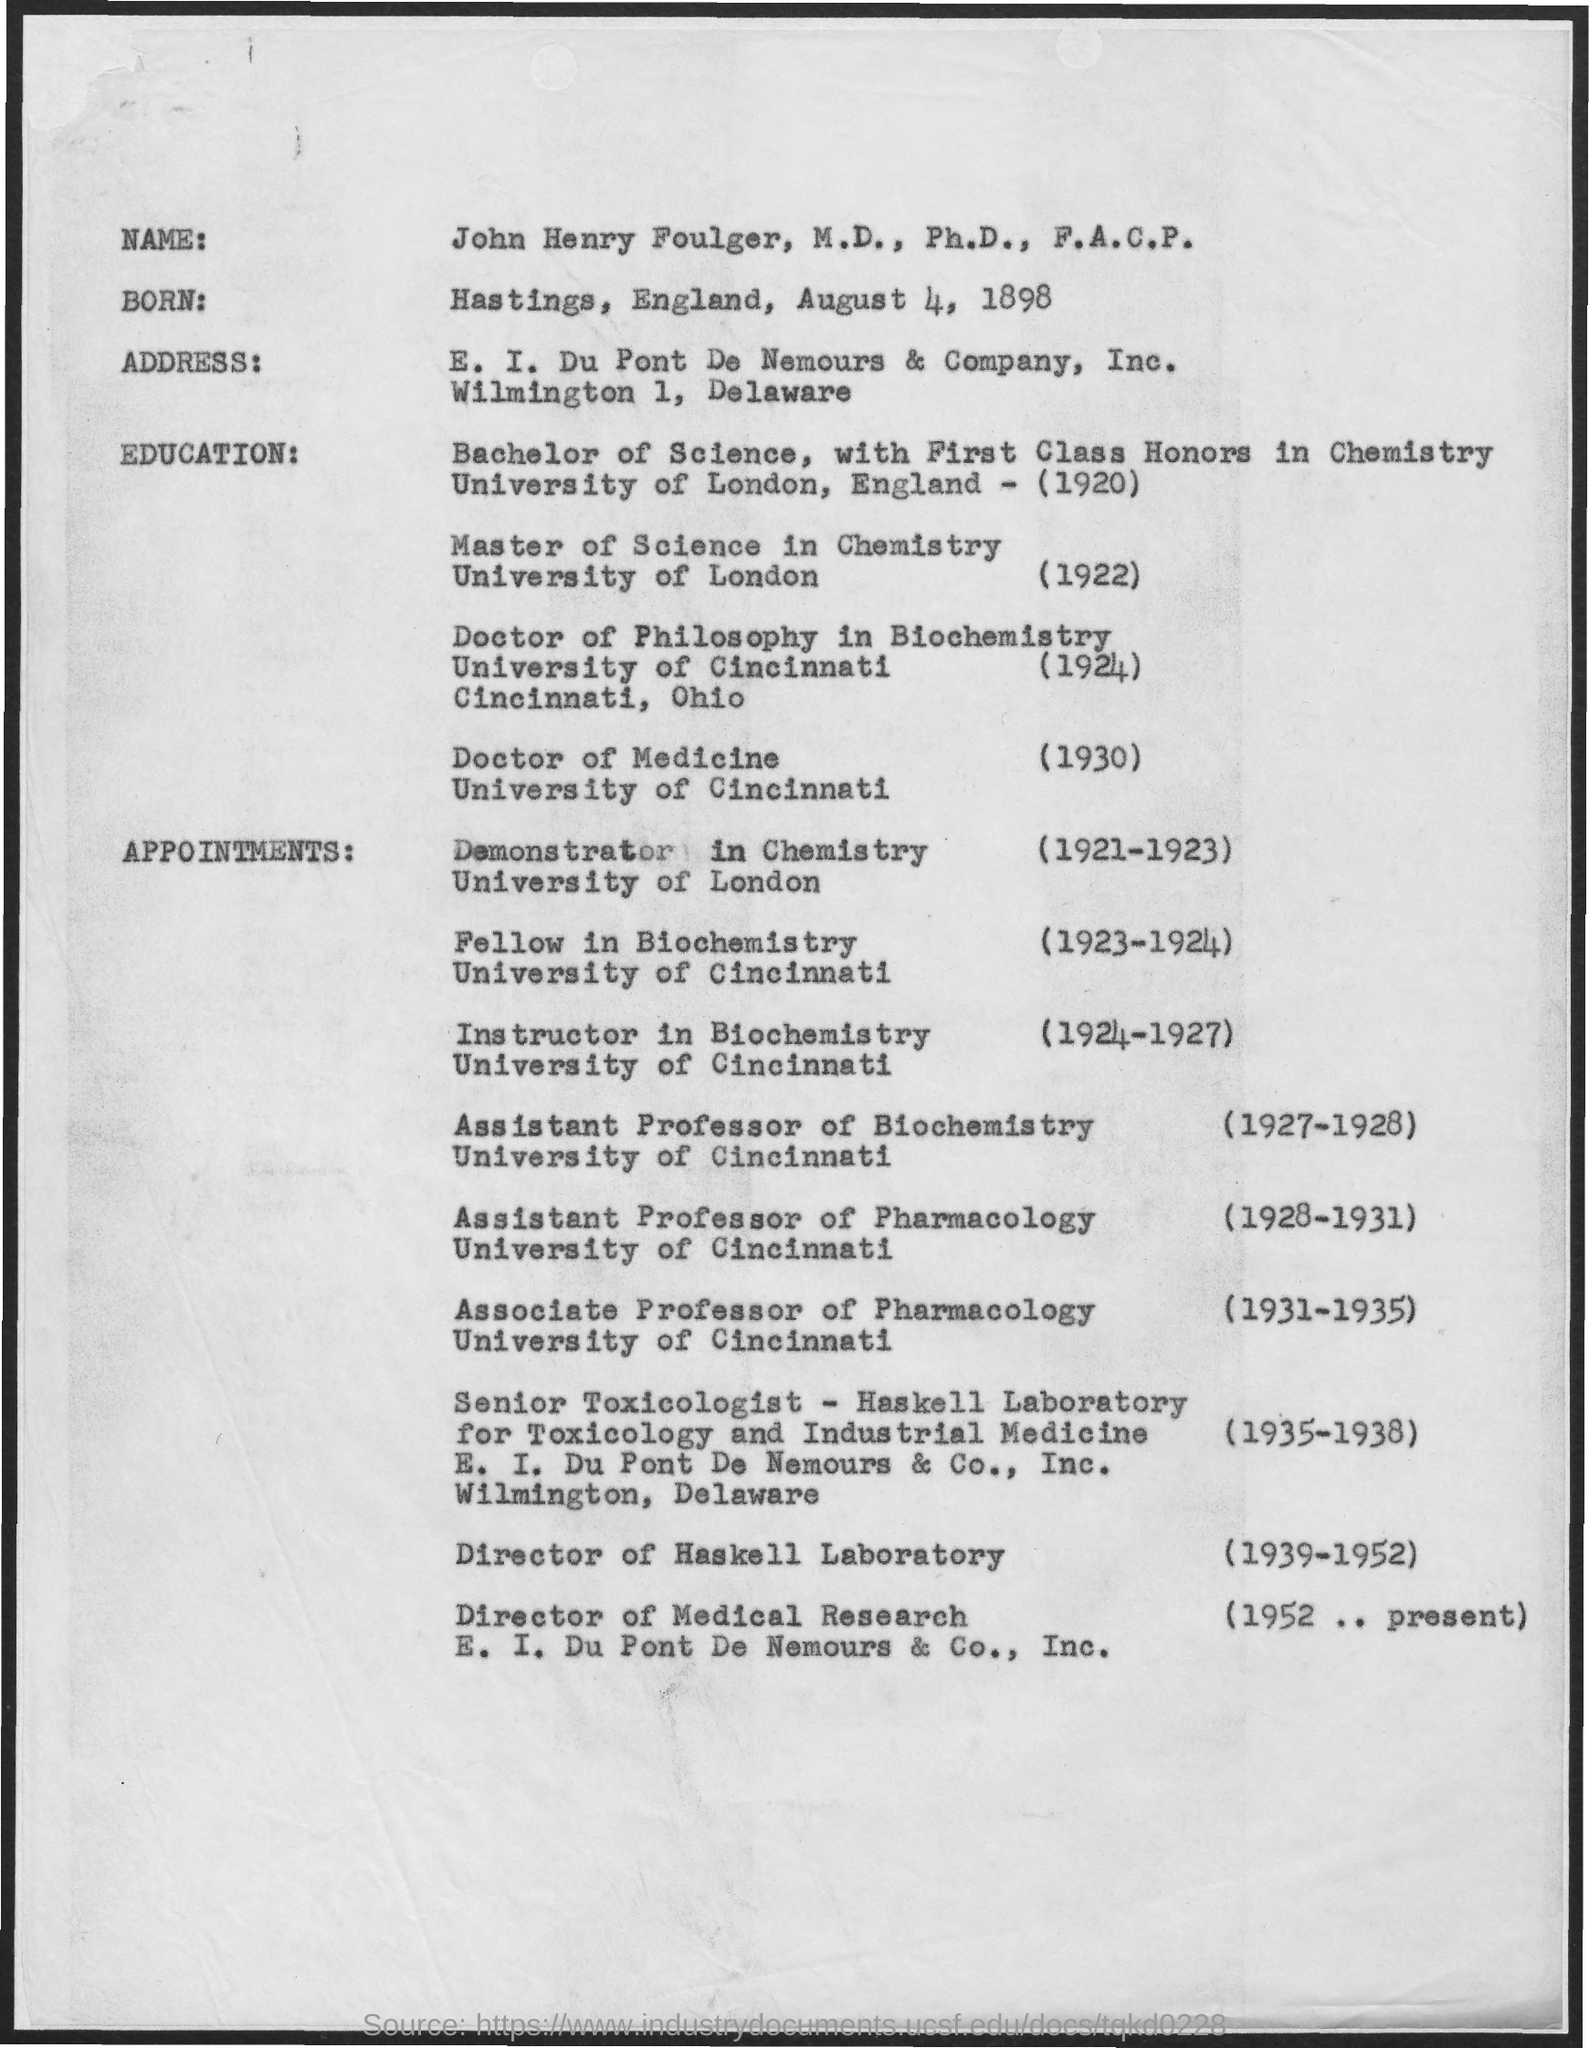When did john henry foulger, m.d., ph.d.,f.a.c.p complete his bachelors degree?
Your response must be concise. 1920. Where did john henry foulger, m.d., ph.d.,f.a.c.p complete his bachelors degree from?
Give a very brief answer. University of london, england. Where did john henry foulger, m.d., ph.d.,f.a.c.p complete his doctor of medicine from?
Keep it short and to the point. University of cincinnati. When did john henry foulger, m.d., ph.d.,f.a.c.p complete his doctor of medicine?
Provide a short and direct response. 1930. 